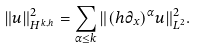<formula> <loc_0><loc_0><loc_500><loc_500>\| u \| _ { H ^ { k , h } } ^ { 2 } = \sum _ { \alpha \leq k } \| ( h \partial _ { x } ) ^ { \alpha } u \| _ { L ^ { 2 } } ^ { 2 } .</formula> 